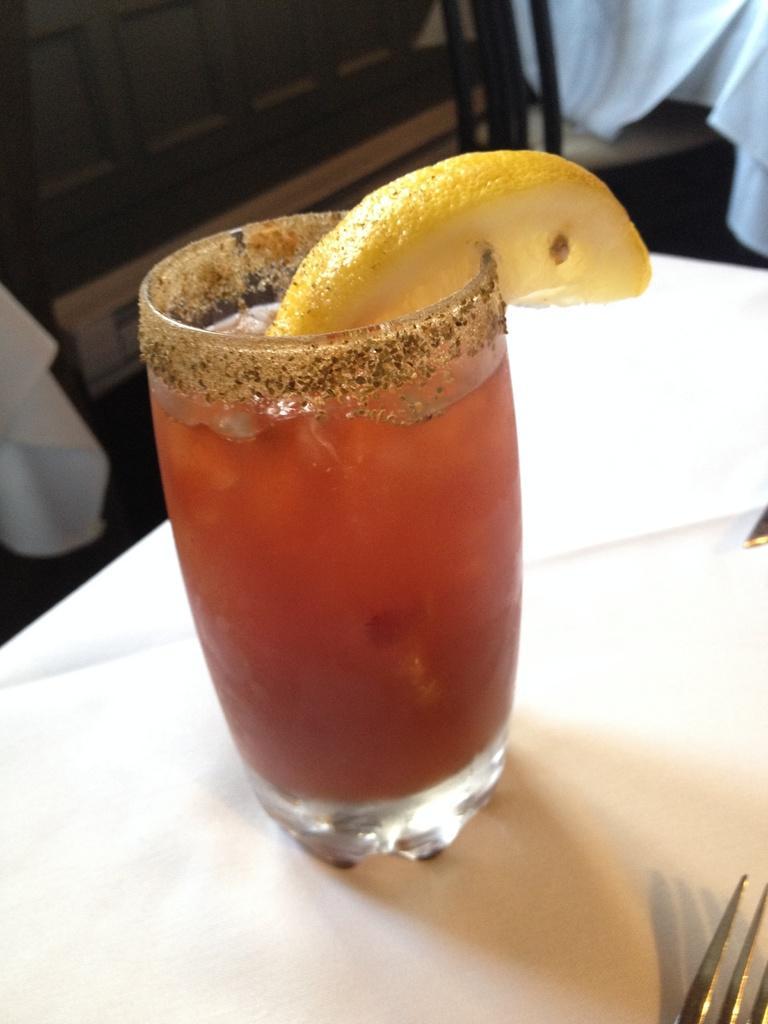In one or two sentences, can you explain what this image depicts? There is a glass of juice, it seems like a lemon on it and a fork in the foreground area of the image, it seems like objects in the background. 